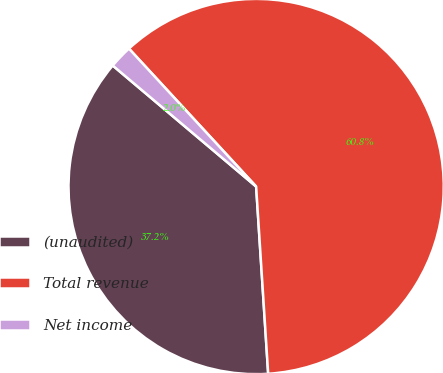Convert chart to OTSL. <chart><loc_0><loc_0><loc_500><loc_500><pie_chart><fcel>(unaudited)<fcel>Total revenue<fcel>Net income<nl><fcel>37.18%<fcel>60.84%<fcel>1.99%<nl></chart> 